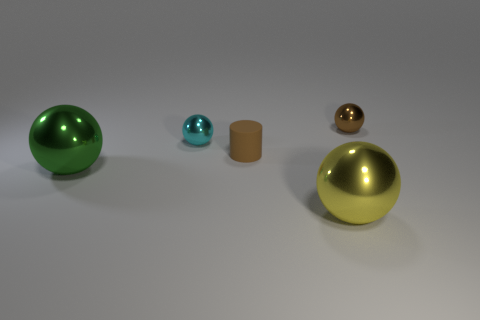Is the number of large red shiny cubes greater than the number of brown rubber cylinders?
Provide a short and direct response. No. There is a green object that is the same shape as the brown metal object; what material is it?
Ensure brevity in your answer.  Metal. Are the small brown sphere and the large green object made of the same material?
Your answer should be very brief. Yes. Are there more metal things behind the matte object than green objects?
Ensure brevity in your answer.  Yes. What is the material of the small ball on the left side of the big metal object that is to the right of the cyan thing that is in front of the brown sphere?
Your answer should be very brief. Metal. What number of objects are either big shiny objects or metallic things left of the small cyan metallic sphere?
Offer a terse response. 2. There is a large thing that is left of the tiny cyan shiny sphere; does it have the same color as the tiny cylinder?
Your response must be concise. No. Is the number of small metallic objects that are in front of the brown shiny sphere greater than the number of tiny brown objects behind the small brown rubber object?
Offer a very short reply. No. Is there any other thing that has the same color as the small cylinder?
Ensure brevity in your answer.  Yes. What number of things are either brown shiny spheres or small purple rubber things?
Your answer should be compact. 1. 